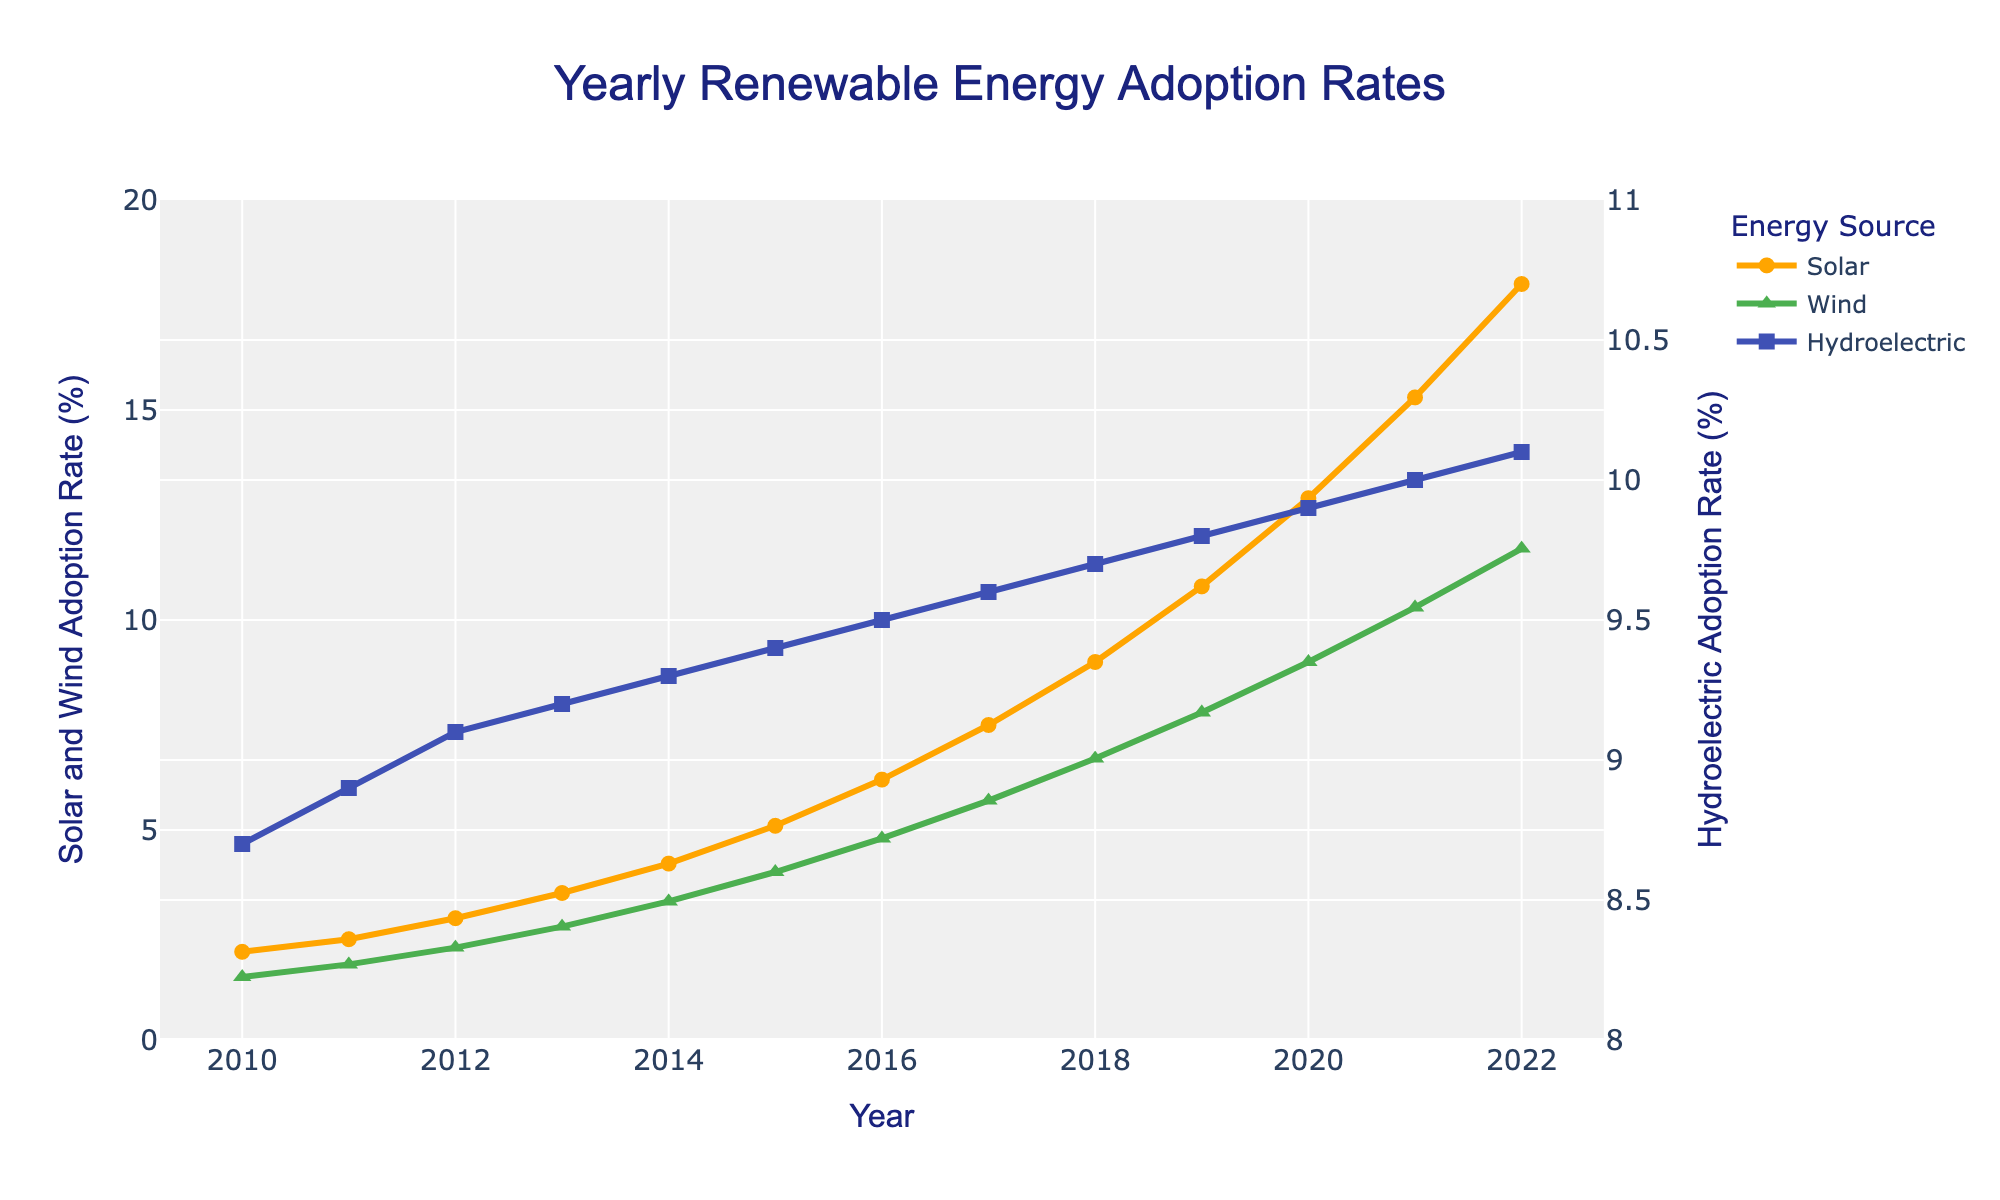What is the adoption rate of solar energy in 2012? Check the rate on the line graph for Solar energy in the year 2012; it is approximately 2.9%.
Answer: 2.9% Which renewable energy source had the highest adoption rate in 2022? Compare the adoption rates for Solar, Wind, and Hydroelectric energy in 2022; Solar had 18.0%, Wind had 11.7%, and Hydroelectric had 10.1%. Solar is the highest.
Answer: Solar By how much did the Wind energy adoption rate increase from 2015 to 2020? Subtract the Wind energy rate in 2015 from the rate in 2020: 9.0% - 4.0% = 5.0%.
Answer: 5.0% Which year saw the greatest increase in adoption rate for Solar energy compared to the previous year? Review the rate change year-over-year for Solar energy and identify the largest increment; from 2019 to 2020, the rate increased from 10.8% to 12.9%, an increase of 2.1%.
Answer: 2020 Calculate the average adoption rate for Hydroelectric energy from 2010 to 2022. Sum the yearly rates of Hydroelectric energy from 2010 to 2022 and divide by the number of years (13): (8.7 + 8.9 + 9.1 + 9.2 + 9.3 + 9.4 + 9.5 + 9.6 + 9.7 + 9.8 + 9.9 + 10.0 + 10.1) / 13 ≈ 9.47%.
Answer: 9.47% What visual marker is used to represent Wind energy in the figure? Observe the shape used for Wind energy in the figure; it is represented by a triangle-up marker.
Answer: triangle-up What is the combined adoption rate for Solar and Wind energy in 2017? Add the adoption rates for Solar and Wind energy in 2017: 7.5% + 5.7% = 13.2%.
Answer: 13.2% Is the Hydroelectric adoption rate trend increasing, decreasing, or stable over the years? Analyze the Hydroelectric adoption rate line; it shows a gradual increase from 8.7% in 2010 to 10.1% in 2022, indicating an increasing trend.
Answer: Increasing Compare the adoption rate growth between Solar and Wind energy from 2010 to 2022. Which one grew more? Calculate the growth for both: Solar grew from 2.1% to 18.0% (15.9% increase), Wind grew from 1.5% to 11.7% (10.2% increase). Solar energy grew more.
Answer: Solar 